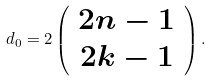<formula> <loc_0><loc_0><loc_500><loc_500>d _ { 0 } = 2 \left ( \begin{array} { c } 2 n - 1 \\ 2 k - 1 \end{array} \right ) .</formula> 